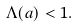<formula> <loc_0><loc_0><loc_500><loc_500>\Lambda ( a ) < 1 .</formula> 